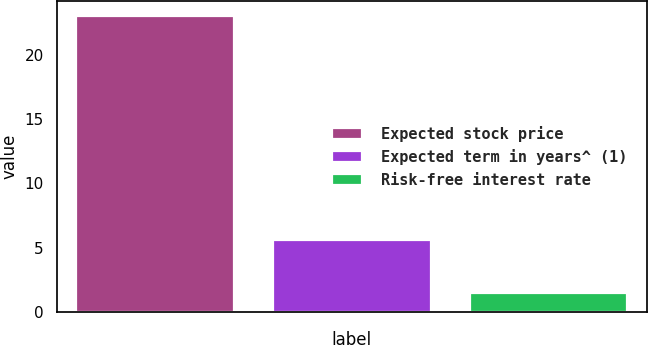Convert chart to OTSL. <chart><loc_0><loc_0><loc_500><loc_500><bar_chart><fcel>Expected stock price<fcel>Expected term in years^ (1)<fcel>Risk-free interest rate<nl><fcel>23<fcel>5.6<fcel>1.5<nl></chart> 